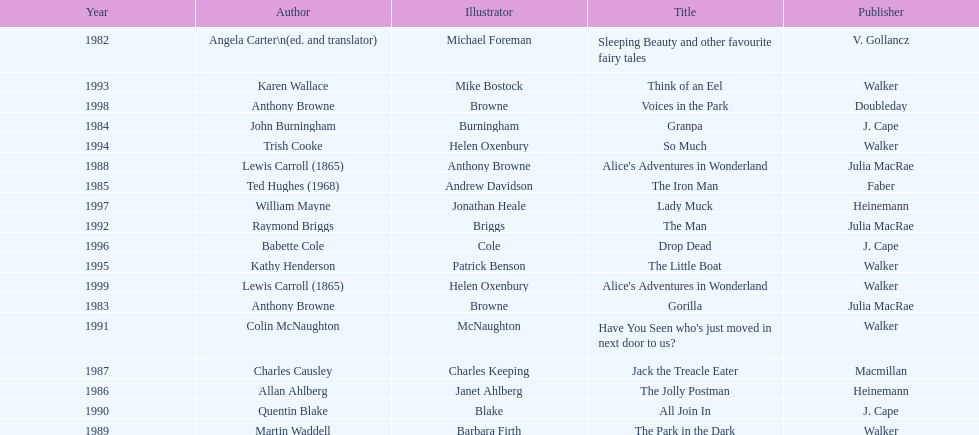How many titles did walker publish? 6. 